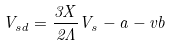<formula> <loc_0><loc_0><loc_500><loc_500>V _ { s d } = \frac { 3 X } { 2 { \Lambda } } V _ { s } - a - v b</formula> 